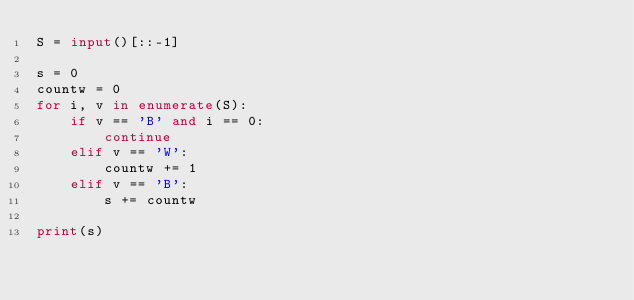Convert code to text. <code><loc_0><loc_0><loc_500><loc_500><_Python_>S = input()[::-1]

s = 0
countw = 0
for i, v in enumerate(S):
    if v == 'B' and i == 0:
        continue
    elif v == 'W':
        countw += 1
    elif v == 'B':
        s += countw

print(s)
</code> 